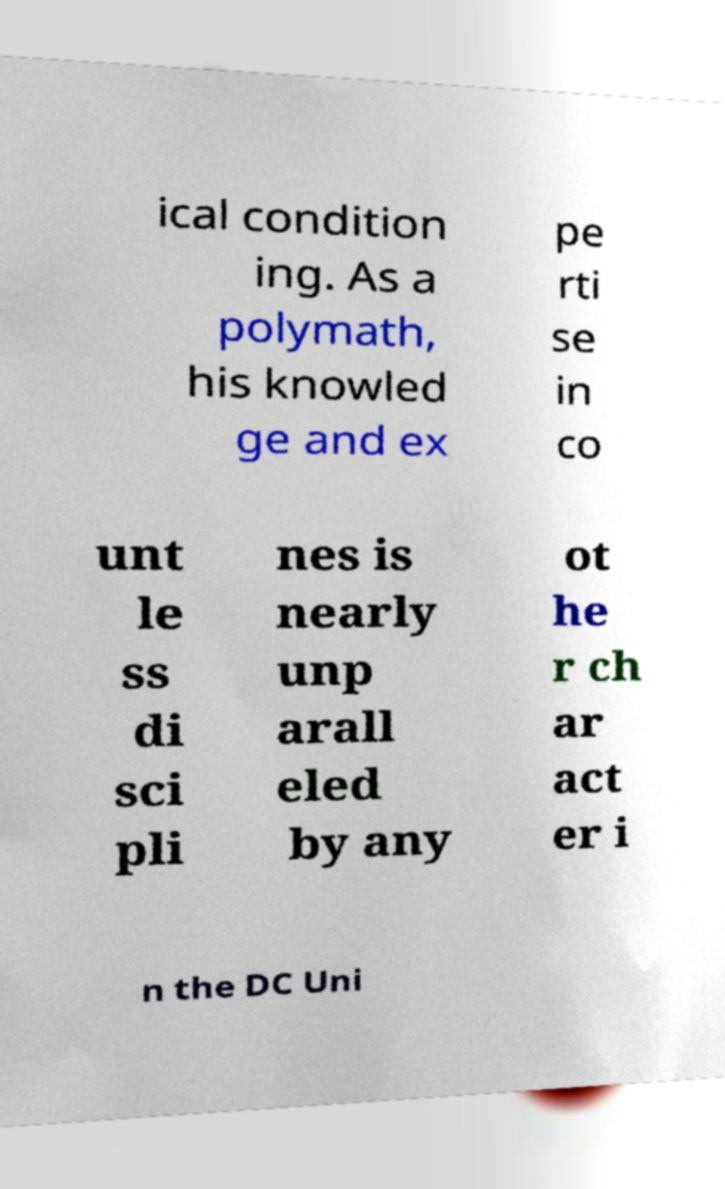Could you assist in decoding the text presented in this image and type it out clearly? ical condition ing. As a polymath, his knowled ge and ex pe rti se in co unt le ss di sci pli nes is nearly unp arall eled by any ot he r ch ar act er i n the DC Uni 